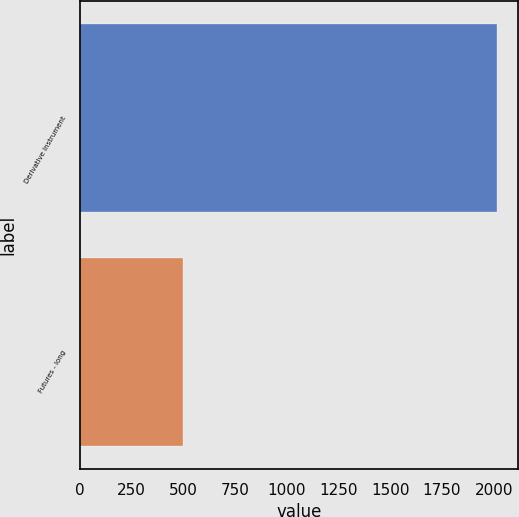<chart> <loc_0><loc_0><loc_500><loc_500><bar_chart><fcel>Derivative Instrument<fcel>Futures - long<nl><fcel>2017<fcel>500<nl></chart> 